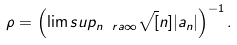Convert formula to latex. <formula><loc_0><loc_0><loc_500><loc_500>\rho = \left ( \lim s u p _ { n \ r a \infty } \sqrt { [ } n ] { | a _ { n } | } \right ) ^ { - 1 } .</formula> 